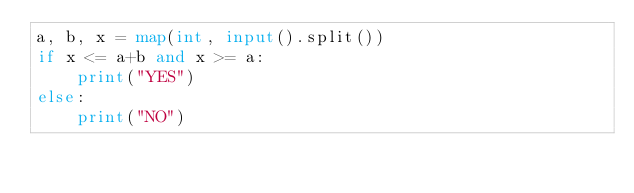<code> <loc_0><loc_0><loc_500><loc_500><_Python_>a, b, x = map(int, input().split())
if x <= a+b and x >= a:
    print("YES")
else:
    print("NO")</code> 